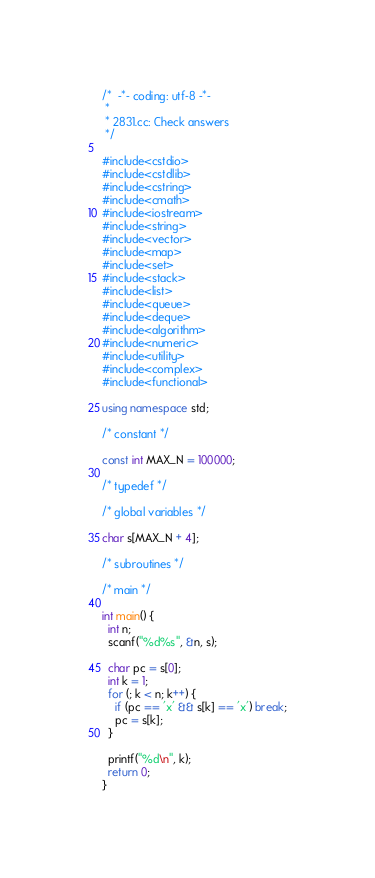Convert code to text. <code><loc_0><loc_0><loc_500><loc_500><_C++_>/*  -*- coding: utf-8 -*-
 *
 * 2831.cc: Check answers
 */

#include<cstdio>
#include<cstdlib>
#include<cstring>
#include<cmath>
#include<iostream>
#include<string>
#include<vector>
#include<map>
#include<set>
#include<stack>
#include<list>
#include<queue>
#include<deque>
#include<algorithm>
#include<numeric>
#include<utility>
#include<complex>
#include<functional>
 
using namespace std;

/* constant */

const int MAX_N = 100000;

/* typedef */

/* global variables */

char s[MAX_N + 4];

/* subroutines */

/* main */

int main() {
  int n;
  scanf("%d%s", &n, s);

  char pc = s[0];
  int k = 1;
  for (; k < n; k++) {
    if (pc == 'x' && s[k] == 'x') break;
    pc = s[k];
  }

  printf("%d\n", k);
  return 0;
}

</code> 